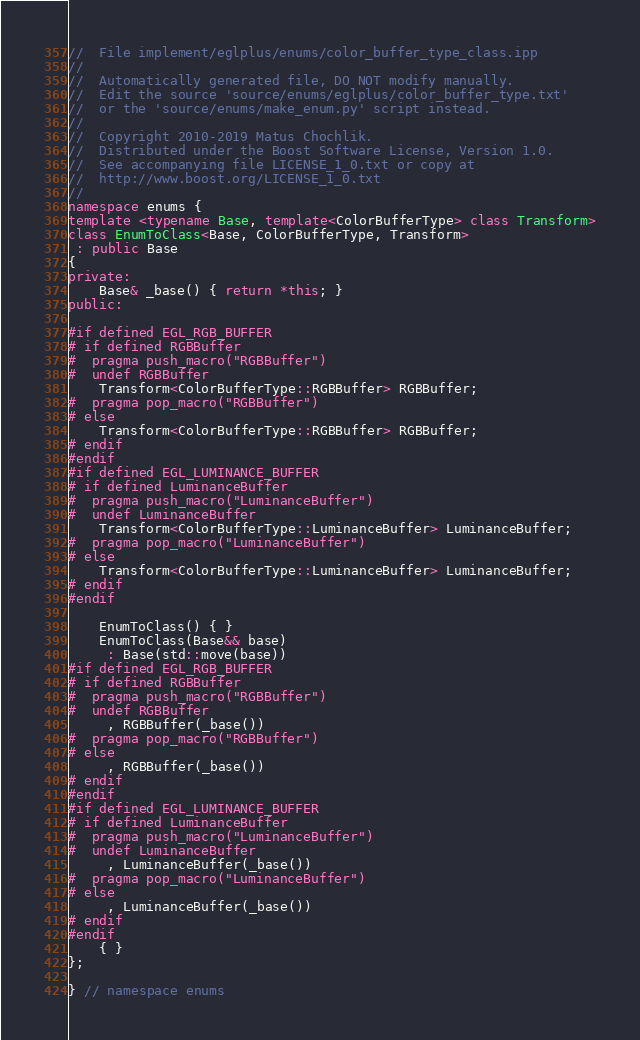<code> <loc_0><loc_0><loc_500><loc_500><_C++_>//  File implement/eglplus/enums/color_buffer_type_class.ipp
//
//  Automatically generated file, DO NOT modify manually.
//  Edit the source 'source/enums/eglplus/color_buffer_type.txt'
//  or the 'source/enums/make_enum.py' script instead.
//
//  Copyright 2010-2019 Matus Chochlik.
//  Distributed under the Boost Software License, Version 1.0.
//  See accompanying file LICENSE_1_0.txt or copy at
//  http://www.boost.org/LICENSE_1_0.txt
//
namespace enums {
template <typename Base, template<ColorBufferType> class Transform>
class EnumToClass<Base, ColorBufferType, Transform>
 : public Base
{
private:
	Base& _base() { return *this; }
public:

#if defined EGL_RGB_BUFFER
# if defined RGBBuffer
#  pragma push_macro("RGBBuffer")
#  undef RGBBuffer
	Transform<ColorBufferType::RGBBuffer> RGBBuffer;
#  pragma pop_macro("RGBBuffer")
# else
	Transform<ColorBufferType::RGBBuffer> RGBBuffer;
# endif
#endif
#if defined EGL_LUMINANCE_BUFFER
# if defined LuminanceBuffer
#  pragma push_macro("LuminanceBuffer")
#  undef LuminanceBuffer
	Transform<ColorBufferType::LuminanceBuffer> LuminanceBuffer;
#  pragma pop_macro("LuminanceBuffer")
# else
	Transform<ColorBufferType::LuminanceBuffer> LuminanceBuffer;
# endif
#endif

	EnumToClass() { }
	EnumToClass(Base&& base)
	 : Base(std::move(base))
#if defined EGL_RGB_BUFFER
# if defined RGBBuffer
#  pragma push_macro("RGBBuffer")
#  undef RGBBuffer
	 , RGBBuffer(_base())
#  pragma pop_macro("RGBBuffer")
# else
	 , RGBBuffer(_base())
# endif
#endif
#if defined EGL_LUMINANCE_BUFFER
# if defined LuminanceBuffer
#  pragma push_macro("LuminanceBuffer")
#  undef LuminanceBuffer
	 , LuminanceBuffer(_base())
#  pragma pop_macro("LuminanceBuffer")
# else
	 , LuminanceBuffer(_base())
# endif
#endif
	{ }
};

} // namespace enums

</code> 